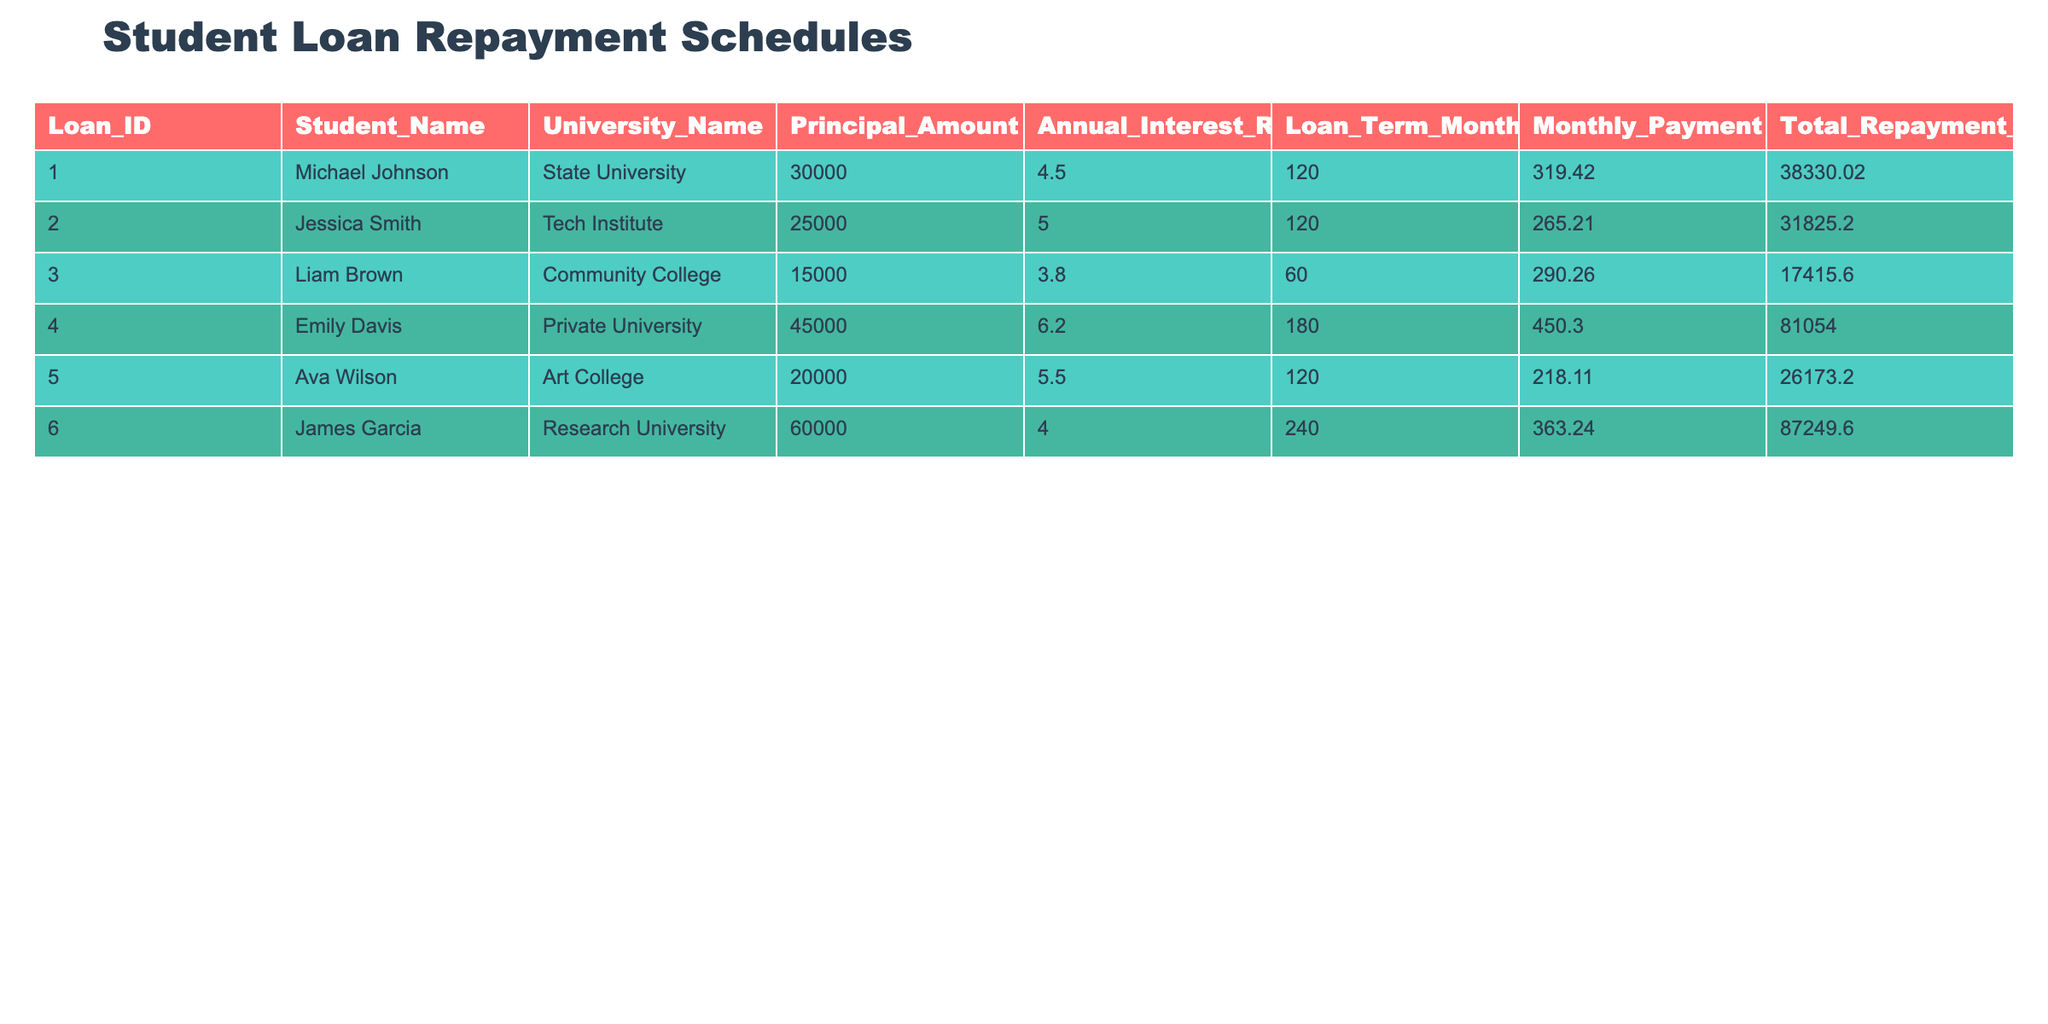What is the Principal Amount for Jessica Smith? The table lists Jessica Smith under the Student_Name column, and by looking at the corresponding row, I can see that her Principal Amount is 25000.
Answer: 25000 Which loan has the highest Total Repayment Amount? By scanning through the Total Repayment Amount column, I find that Emily Davis's loan has the highest amount at 81054.00.
Answer: 81054.00 What is the average Monthly Payment of all loans? I sum up the Monthly Payments: 319.42 + 265.21 + 290.26 + 450.30 + 218.11 + 363.24 = 1976.54. Then, I divide by the number of loans (6): 1976.54 / 6 = 329.42.
Answer: 329.42 Does Liam Brown's loan have a lower Annual Interest Rate than Ava Wilson's loan? Liam Brown's Annual Interest Rate is 3.8 while Ava Wilson's is 5.5. Since 3.8 is less than 5.5, the answer is yes.
Answer: Yes What is the difference in Principal Amounts between the loans for Emily Davis and Liam Brown? Emily Davis's Principal Amount is 45000, while Liam Brown's is 15000. The difference is 45000 - 15000 = 30000.
Answer: 30000 What percentage of the Total Repayment Amount does James Garcia's loan represent compared to the total of all loans? First, I find the total repayment amounts: 38330.02 + 31825.20 + 17415.60 + 81054.00 + 26173.20 + 87249.60 = 181047.62. Then, I calculate James Garcia's portion: 87249.60 / 181047.62 * 100 = 48.24%.
Answer: 48.24% Is the Monthly Payment for Michael Johnson higher than the Monthly Payment for Ava Wilson? Michael Johnson's Monthly Payment is 319.42, while Ava Wilson's is 218.11. Since 319.42 is greater than 218.11, the answer is yes.
Answer: Yes 